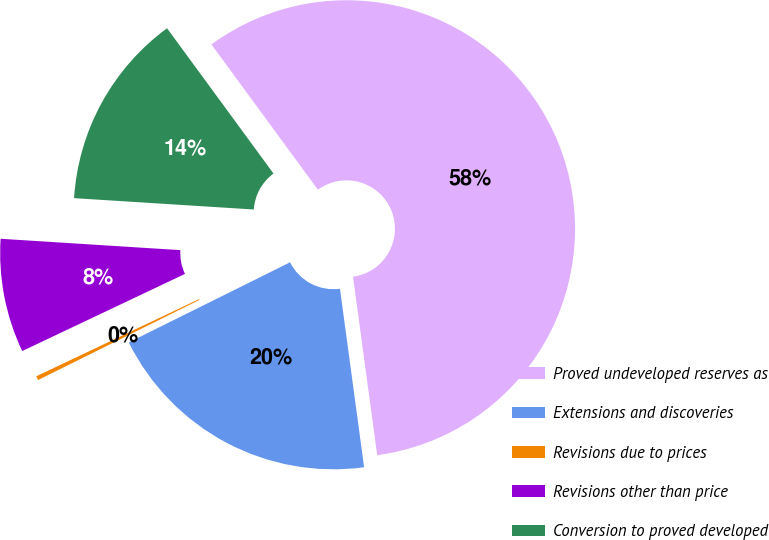Convert chart. <chart><loc_0><loc_0><loc_500><loc_500><pie_chart><fcel>Proved undeveloped reserves as<fcel>Extensions and discoveries<fcel>Revisions due to prices<fcel>Revisions other than price<fcel>Conversion to proved developed<nl><fcel>57.93%<fcel>19.81%<fcel>0.29%<fcel>8.05%<fcel>13.93%<nl></chart> 